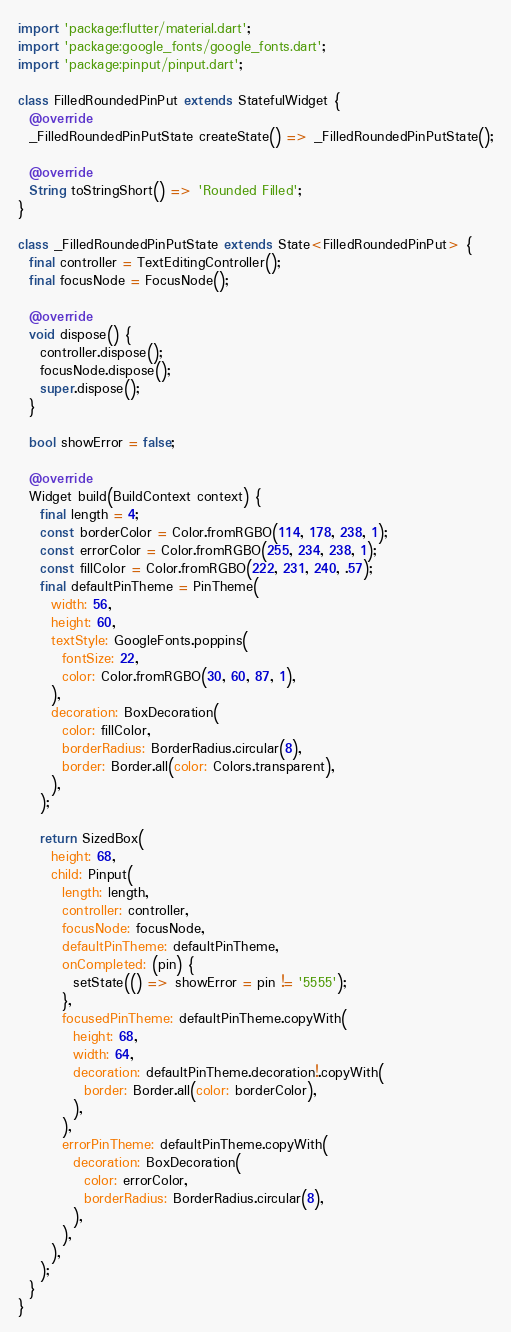<code> <loc_0><loc_0><loc_500><loc_500><_Dart_>import 'package:flutter/material.dart';
import 'package:google_fonts/google_fonts.dart';
import 'package:pinput/pinput.dart';

class FilledRoundedPinPut extends StatefulWidget {
  @override
  _FilledRoundedPinPutState createState() => _FilledRoundedPinPutState();

  @override
  String toStringShort() => 'Rounded Filled';
}

class _FilledRoundedPinPutState extends State<FilledRoundedPinPut> {
  final controller = TextEditingController();
  final focusNode = FocusNode();

  @override
  void dispose() {
    controller.dispose();
    focusNode.dispose();
    super.dispose();
  }

  bool showError = false;

  @override
  Widget build(BuildContext context) {
    final length = 4;
    const borderColor = Color.fromRGBO(114, 178, 238, 1);
    const errorColor = Color.fromRGBO(255, 234, 238, 1);
    const fillColor = Color.fromRGBO(222, 231, 240, .57);
    final defaultPinTheme = PinTheme(
      width: 56,
      height: 60,
      textStyle: GoogleFonts.poppins(
        fontSize: 22,
        color: Color.fromRGBO(30, 60, 87, 1),
      ),
      decoration: BoxDecoration(
        color: fillColor,
        borderRadius: BorderRadius.circular(8),
        border: Border.all(color: Colors.transparent),
      ),
    );

    return SizedBox(
      height: 68,
      child: Pinput(
        length: length,
        controller: controller,
        focusNode: focusNode,
        defaultPinTheme: defaultPinTheme,
        onCompleted: (pin) {
          setState(() => showError = pin != '5555');
        },
        focusedPinTheme: defaultPinTheme.copyWith(
          height: 68,
          width: 64,
          decoration: defaultPinTheme.decoration!.copyWith(
            border: Border.all(color: borderColor),
          ),
        ),
        errorPinTheme: defaultPinTheme.copyWith(
          decoration: BoxDecoration(
            color: errorColor,
            borderRadius: BorderRadius.circular(8),
          ),
        ),
      ),
    );
  }
}
</code> 